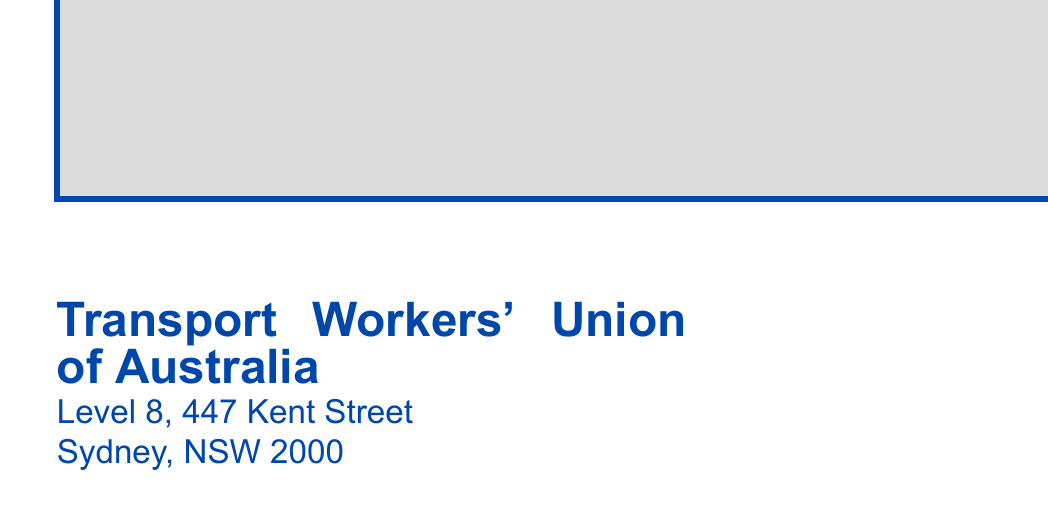What is the name of the union? The union is identified in the document as the Transport Workers' Union of Australia.
Answer: Transport Workers' Union of Australia What is the address of the union? The union's address is stated in the document and includes Level 8, 447 Kent Street, Sydney, NSW 2000.
Answer: Level 8, 447 Kent Street, Sydney, NSW 2000 What is highlighted as important in the document? The document prominently mentions an "Important Union Meeting Notification," indicating the focus of the message.
Answer: Important Union Meeting Notification What is the size of the document font? The document specifies a font size of 12pt for the letter content, indicating the size used throughout.
Answer: 12pt Who is the recipient of the letter? The document includes a placeholder for the recipient's name, which denotes the intended reader of the communication.
Answer: Employee Name What is the type of document? This document is classified as a notification letter concerning a union meeting, specific to union members.
Answer: Notification letter What color is used for the border of the document? The border color in the document is a shade of blue, specifically referred to as twublue.
Answer: twublue What is the significance of the graphic included? The document includes a graphic element, generally representing the union's logo or branding, which adds credibility to the communication.
Answer: Union logo What does the document indicate about the meeting? While the document does not specify details about the meeting, it certainly highlights the importance of attending.
Answer: Importance of attendance 